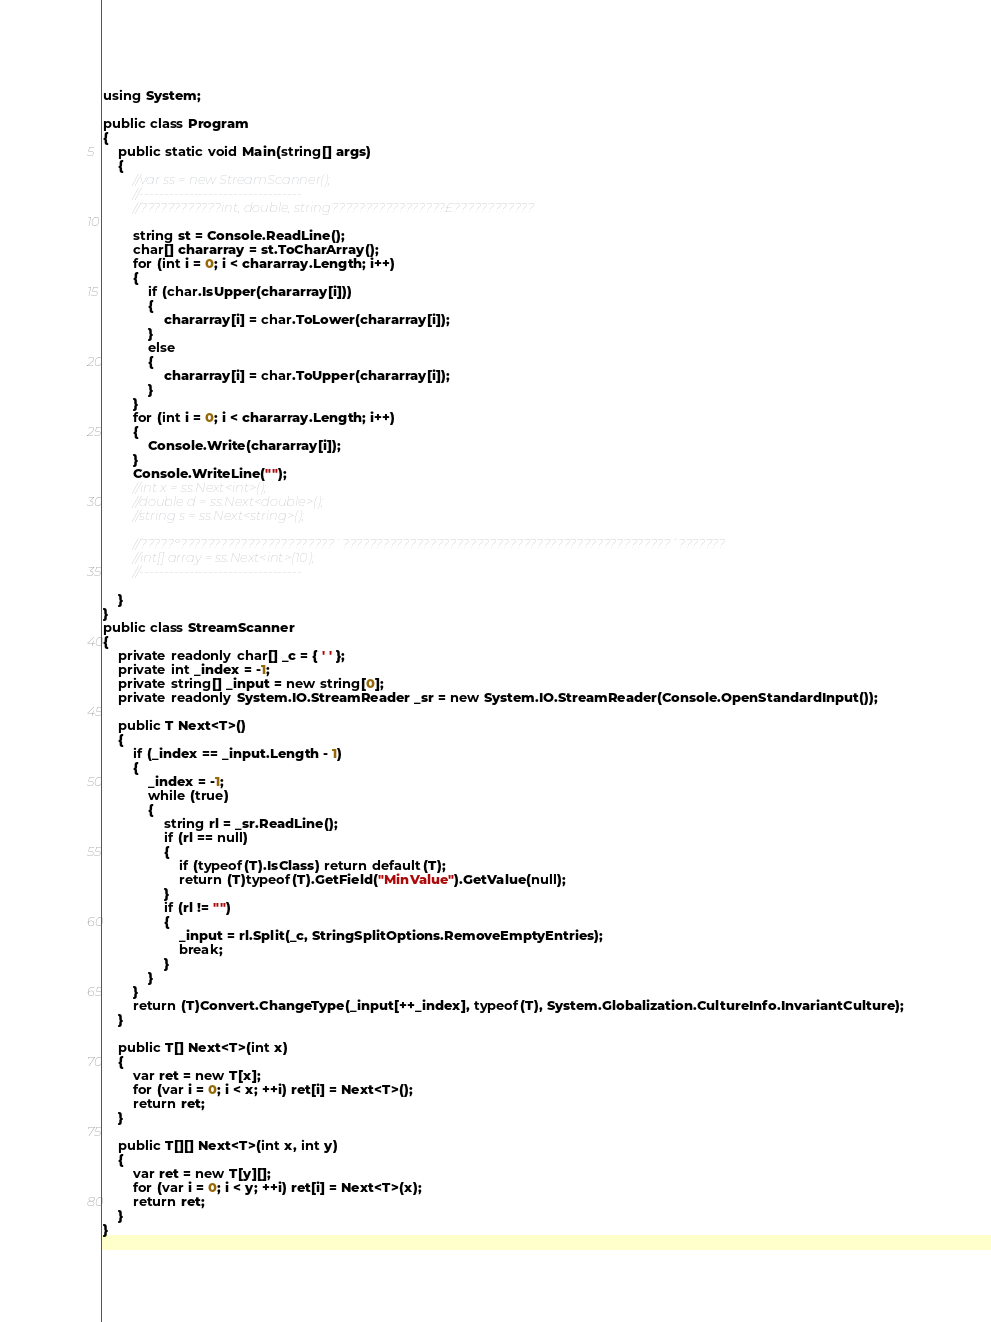Convert code to text. <code><loc_0><loc_0><loc_500><loc_500><_C#_>using System;

public class Program
{
	public static void Main(string[] args)
	{
		//var ss = new StreamScanner();
		//---------------------------------
		//????????????int, double, string?????????????????£????????????

		string st = Console.ReadLine();
		char[] chararray = st.ToCharArray();
		for (int i = 0; i < chararray.Length; i++)
		{
			if (char.IsUpper(chararray[i]))
			{
				chararray[i] = char.ToLower(chararray[i]);
			}
			else
			{
				chararray[i] = char.ToUpper(chararray[i]);
			}
		}
		for (int i = 0; i < chararray.Length; i++)
		{
			Console.Write(chararray[i]);
		}
		Console.WriteLine("");
		//int x = ss.Next<int>();
		//double d = ss.Next<double>();
		//string s = ss.Next<string>();

		//?????°???????????????????????¨?????????????????????????????????????????????????´???????
		//int[] array = ss.Next<int>(10);
		//---------------------------------

	}
}
public class StreamScanner
{
	private readonly char[] _c = { ' ' };
	private int _index = -1;
	private string[] _input = new string[0];
	private readonly System.IO.StreamReader _sr = new System.IO.StreamReader(Console.OpenStandardInput());

	public T Next<T>()
	{
		if (_index == _input.Length - 1)
		{
			_index = -1;
			while (true)
			{
				string rl = _sr.ReadLine();
				if (rl == null)
				{
					if (typeof(T).IsClass) return default(T);
					return (T)typeof(T).GetField("MinValue").GetValue(null);
				}
				if (rl != "")
				{
					_input = rl.Split(_c, StringSplitOptions.RemoveEmptyEntries);
					break;
				}
			}
		}
		return (T)Convert.ChangeType(_input[++_index], typeof(T), System.Globalization.CultureInfo.InvariantCulture);
	}

	public T[] Next<T>(int x)
	{
		var ret = new T[x];
		for (var i = 0; i < x; ++i) ret[i] = Next<T>();
		return ret;
	}

	public T[][] Next<T>(int x, int y)
	{
		var ret = new T[y][];
		for (var i = 0; i < y; ++i) ret[i] = Next<T>(x);
		return ret;
	}
}</code> 